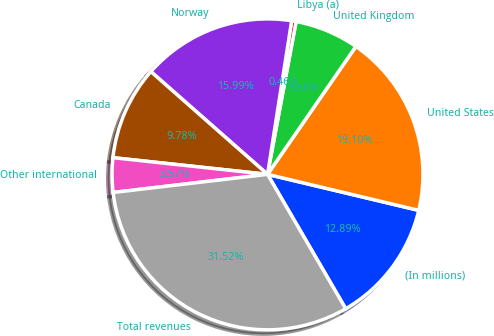Convert chart. <chart><loc_0><loc_0><loc_500><loc_500><pie_chart><fcel>(In millions)<fcel>United States<fcel>United Kingdom<fcel>Libya (a)<fcel>Norway<fcel>Canada<fcel>Other international<fcel>Total revenues<nl><fcel>12.89%<fcel>19.1%<fcel>6.68%<fcel>0.46%<fcel>15.99%<fcel>9.78%<fcel>3.57%<fcel>31.52%<nl></chart> 